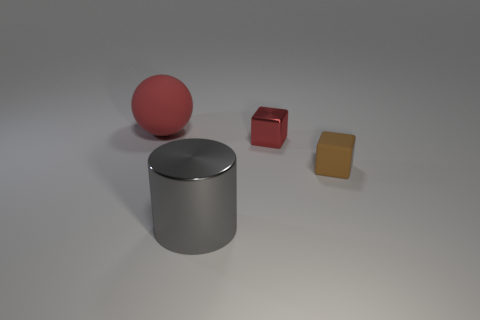Can you describe the lighting in the scene? The image is illuminated by a soft, diffused light source, as evidenced by the gentle shadows beneath the objects. There is no harsh glare or dramatic contrast, which creates a calm and evenly lit environment, highlighting the objects without sharp reflections. 